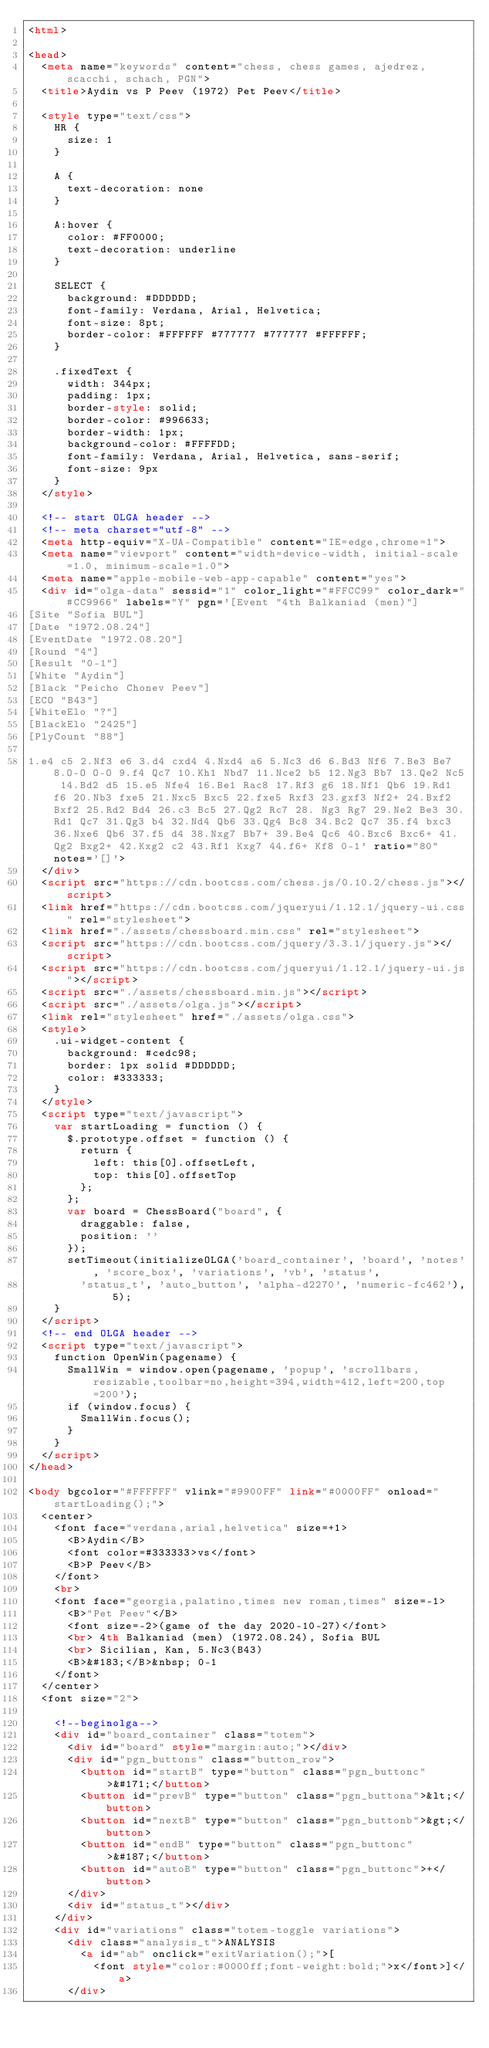Convert code to text. <code><loc_0><loc_0><loc_500><loc_500><_HTML_><html>

<head>
  <meta name="keywords" content="chess, chess games, ajedrez, scacchi, schach, PGN">
  <title>Aydin vs P Peev (1972) Pet Peev</title>

  <style type="text/css">
    HR {
      size: 1
    }

    A {
      text-decoration: none
    }

    A:hover {
      color: #FF0000;
      text-decoration: underline
    }

    SELECT {
      background: #DDDDDD;
      font-family: Verdana, Arial, Helvetica;
      font-size: 8pt;
      border-color: #FFFFFF #777777 #777777 #FFFFFF;
    }

    .fixedText {
      width: 344px;
      padding: 1px;
      border-style: solid;
      border-color: #996633;
      border-width: 1px;
      background-color: #FFFFDD;
      font-family: Verdana, Arial, Helvetica, sans-serif;
      font-size: 9px
    }
  </style>

  <!-- start OLGA header -->
  <!-- meta charset="utf-8" -->
  <meta http-equiv="X-UA-Compatible" content="IE=edge,chrome=1">
  <meta name="viewport" content="width=device-width, initial-scale=1.0, minimum-scale=1.0">
  <meta name="apple-mobile-web-app-capable" content="yes">
  <div id="olga-data" sessid="1" color_light="#FFCC99" color_dark="#CC9966" labels="Y" pgn='[Event "4th Balkaniad (men)"]
[Site "Sofia BUL"]
[Date "1972.08.24"]
[EventDate "1972.08.20"]
[Round "4"]
[Result "0-1"]
[White "Aydin"]
[Black "Peicho Chonev Peev"]
[ECO "B43"]
[WhiteElo "?"]
[BlackElo "2425"]
[PlyCount "88"]

1.e4 c5 2.Nf3 e6 3.d4 cxd4 4.Nxd4 a6 5.Nc3 d6 6.Bd3 Nf6 7.Be3 Be7 8.O-O O-O 9.f4 Qc7 10.Kh1 Nbd7 11.Nce2 b5 12.Ng3 Bb7 13.Qe2 Nc5 14.Bd2 d5 15.e5 Nfe4 16.Be1 Rac8 17.Rf3 g6 18.Nf1 Qb6 19.Rd1 f6 20.Nb3 fxe5 21.Nxc5 Bxc5 22.fxe5 Rxf3 23.gxf3 Nf2+ 24.Bxf2 Bxf2 25.Rd2 Bd4 26.c3 Bc5 27.Qg2 Rc7 28. Ng3 Rg7 29.Ne2 Be3 30.Rd1 Qc7 31.Qg3 b4 32.Nd4 Qb6 33.Qg4 Bc8 34.Bc2 Qc7 35.f4 bxc3 36.Nxe6 Qb6 37.f5 d4 38.Nxg7 Bb7+ 39.Be4 Qc6 40.Bxc6 Bxc6+ 41. Qg2 Bxg2+ 42.Kxg2 c2 43.Rf1 Kxg7 44.f6+ Kf8 0-1' ratio="80" notes='[]'>
  </div>
  <script src="https://cdn.bootcss.com/chess.js/0.10.2/chess.js"></script>
  <link href="https://cdn.bootcss.com/jqueryui/1.12.1/jquery-ui.css" rel="stylesheet">
  <link href="./assets/chessboard.min.css" rel="stylesheet">
  <script src="https://cdn.bootcss.com/jquery/3.3.1/jquery.js"></script>
  <script src="https://cdn.bootcss.com/jqueryui/1.12.1/jquery-ui.js"></script>
  <script src="./assets/chessboard.min.js"></script>
  <script src="./assets/olga.js"></script>
  <link rel="stylesheet" href="./assets/olga.css">
  <style>
    .ui-widget-content {
      background: #cedc98;
      border: 1px solid #DDDDDD;
      color: #333333;
    }
  </style>
  <script type="text/javascript">
    var startLoading = function () {
      $.prototype.offset = function () {
        return {
          left: this[0].offsetLeft,
          top: this[0].offsetTop
        };
      };
      var board = ChessBoard("board", {
        draggable: false,
        position: ''
      });
      setTimeout(initializeOLGA('board_container', 'board', 'notes', 'score_box', 'variations', 'vb', 'status',
        'status_t', 'auto_button', 'alpha-d2270', 'numeric-fc462'), 5);
    }
  </script>
  <!-- end OLGA header -->
  <script type="text/javascript">
    function OpenWin(pagename) {
      SmallWin = window.open(pagename, 'popup', 'scrollbars,resizable,toolbar=no,height=394,width=412,left=200,top=200');
      if (window.focus) {
        SmallWin.focus();
      }
    }
  </script>
</head>

<body bgcolor="#FFFFFF" vlink="#9900FF" link="#0000FF" onload="startLoading();">
  <center>
    <font face="verdana,arial,helvetica" size=+1>
      <B>Aydin</B>
      <font color=#333333>vs</font>
      <B>P Peev</B>
    </font>
    <br>
    <font face="georgia,palatino,times new roman,times" size=-1>
      <B>"Pet Peev"</B>
      <font size=-2>(game of the day 2020-10-27)</font>
      <br> 4th Balkaniad (men) (1972.08.24), Sofia BUL
      <br> Sicilian, Kan, 5.Nc3(B43)
      <B>&#183;</B>&nbsp; 0-1
    </font>
  </center>
  <font size="2">

    <!--beginolga-->
    <div id="board_container" class="totem">
      <div id="board" style="margin:auto;"></div>
      <div id="pgn_buttons" class="button_row">
        <button id="startB" type="button" class="pgn_buttonc">&#171;</button>
        <button id="prevB" type="button" class="pgn_buttona">&lt;</button>
        <button id="nextB" type="button" class="pgn_buttonb">&gt;</button>
        <button id="endB" type="button" class="pgn_buttonc">&#187;</button>
        <button id="autoB" type="button" class="pgn_buttonc">+</button>
      </div>
      <div id="status_t"></div>
    </div>
    <div id="variations" class="totem-toggle variations">
      <div class="analysis_t">ANALYSIS
        <a id="ab" onclick="exitVariation();">[
          <font style="color:#0000ff;font-weight:bold;">x</font>]</a>
      </div></code> 